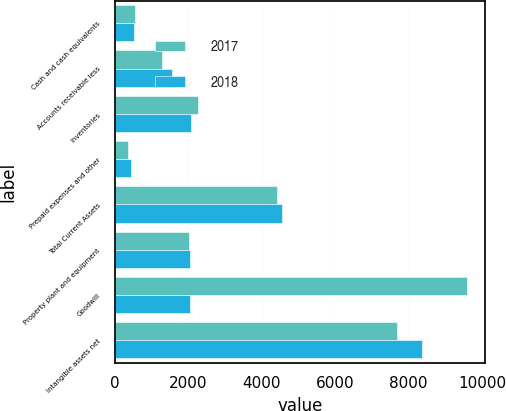Convert chart. <chart><loc_0><loc_0><loc_500><loc_500><stacked_bar_chart><ecel><fcel>Cash and cash equivalents<fcel>Accounts receivable less<fcel>Inventories<fcel>Prepaid expenses and other<fcel>Total Current Assets<fcel>Property plant and equipment<fcel>Goodwill<fcel>Intangible assets net<nl><fcel>2017<fcel>542.8<fcel>1275.8<fcel>2256.5<fcel>352.3<fcel>4427.4<fcel>2015.4<fcel>9594.4<fcel>7684.6<nl><fcel>2018<fcel>524.4<fcel>1544.1<fcel>2068.3<fcel>428<fcel>4564.8<fcel>2038.6<fcel>2038.6<fcel>8353.4<nl></chart> 